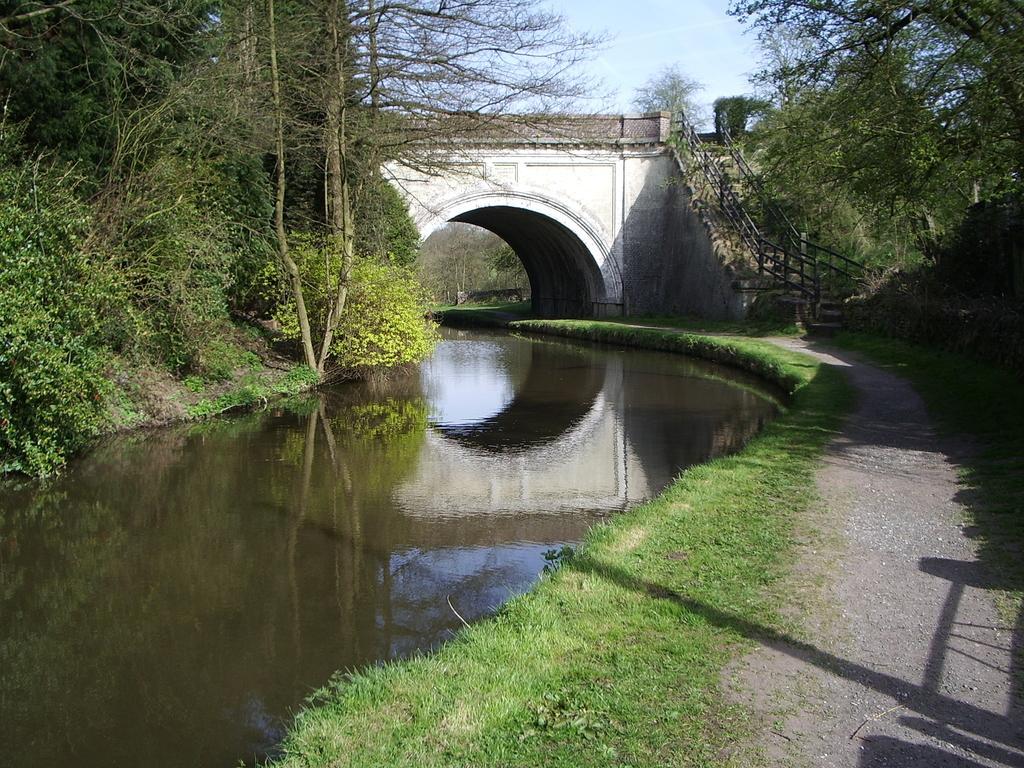Please provide a concise description of this image. In this picture we can see water, beside to the water we can find few trees, and also we can see a bridge over the water. 